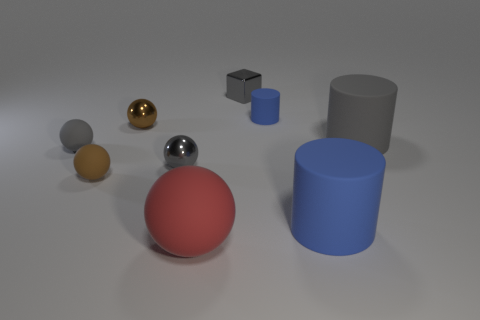There is a tiny shiny object that is the same color as the shiny block; what shape is it?
Your answer should be compact. Sphere. The cylinder that is the same size as the brown matte thing is what color?
Your response must be concise. Blue. How big is the blue object that is in front of the blue rubber cylinder that is behind the brown shiny ball?
Provide a succinct answer. Large. What is the size of the matte thing that is the same color as the small cylinder?
Ensure brevity in your answer.  Large. How many other things are the same size as the red rubber thing?
Offer a terse response. 2. What number of small spheres are there?
Your answer should be very brief. 4. Do the brown metal sphere and the gray matte sphere have the same size?
Make the answer very short. Yes. What number of other things are there of the same shape as the brown matte thing?
Make the answer very short. 4. The small gray object to the right of the large sphere that is to the right of the gray rubber ball is made of what material?
Provide a short and direct response. Metal. There is a brown matte ball; are there any tiny cylinders in front of it?
Your answer should be very brief. No. 